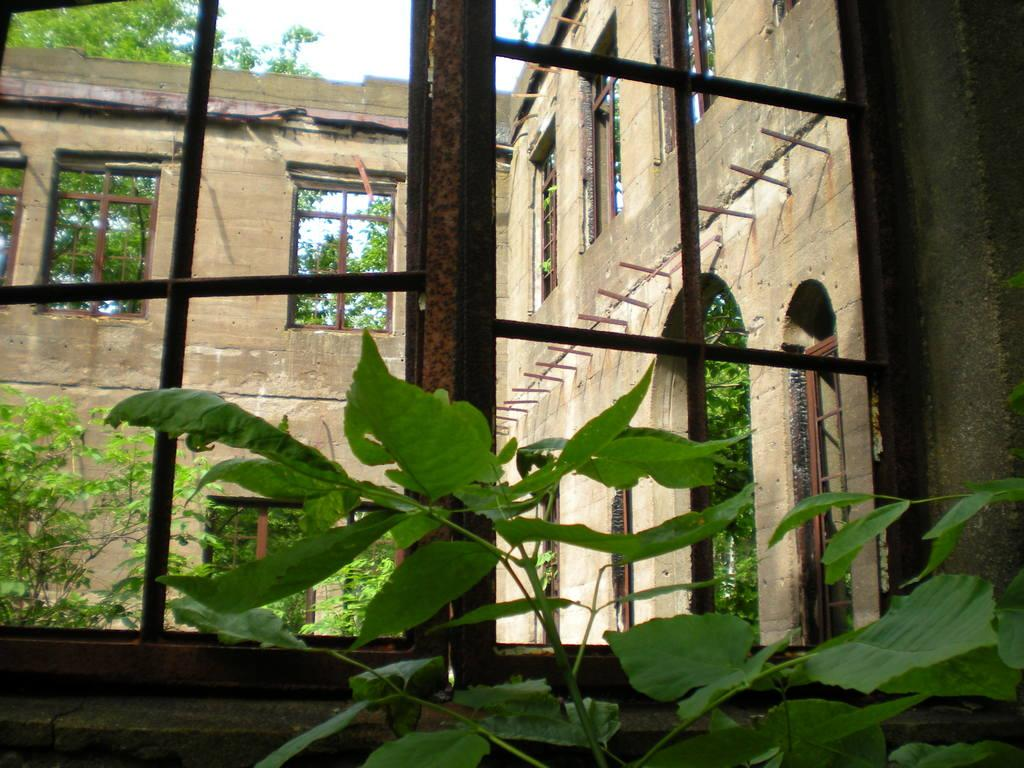What type of living organisms can be seen in the image? Plants can be seen in the image. What architectural features are present in the image? There are windows and walls visible in the image. What type of natural vegetation is visible in the image? There are trees in the image. What type of control panel can be seen in the image? There is no control panel present in the image. What type of reading material is visible in the image? There is no reading material visible in the image. 